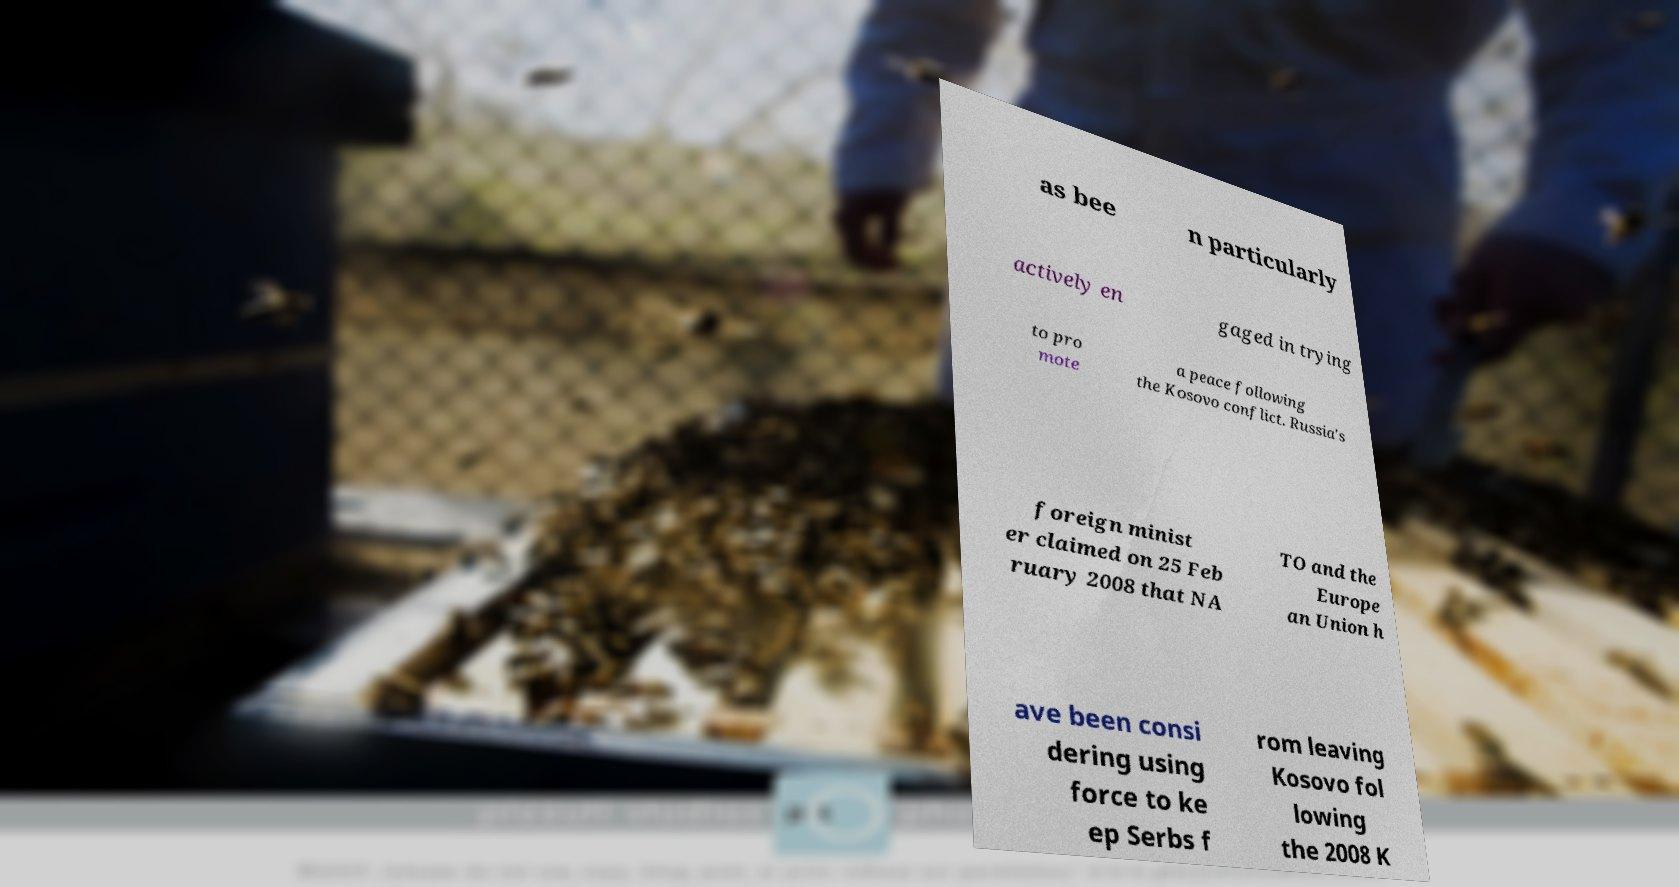Can you read and provide the text displayed in the image?This photo seems to have some interesting text. Can you extract and type it out for me? as bee n particularly actively en gaged in trying to pro mote a peace following the Kosovo conflict. Russia's foreign minist er claimed on 25 Feb ruary 2008 that NA TO and the Europe an Union h ave been consi dering using force to ke ep Serbs f rom leaving Kosovo fol lowing the 2008 K 